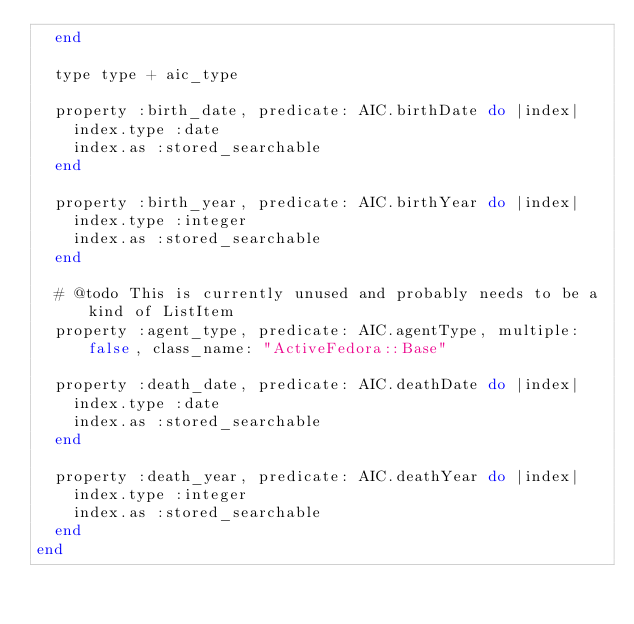<code> <loc_0><loc_0><loc_500><loc_500><_Ruby_>  end

  type type + aic_type

  property :birth_date, predicate: AIC.birthDate do |index|
    index.type :date
    index.as :stored_searchable
  end

  property :birth_year, predicate: AIC.birthYear do |index|
    index.type :integer
    index.as :stored_searchable
  end

  # @todo This is currently unused and probably needs to be a kind of ListItem
  property :agent_type, predicate: AIC.agentType, multiple: false, class_name: "ActiveFedora::Base"

  property :death_date, predicate: AIC.deathDate do |index|
    index.type :date
    index.as :stored_searchable
  end

  property :death_year, predicate: AIC.deathYear do |index|
    index.type :integer
    index.as :stored_searchable
  end
end
</code> 